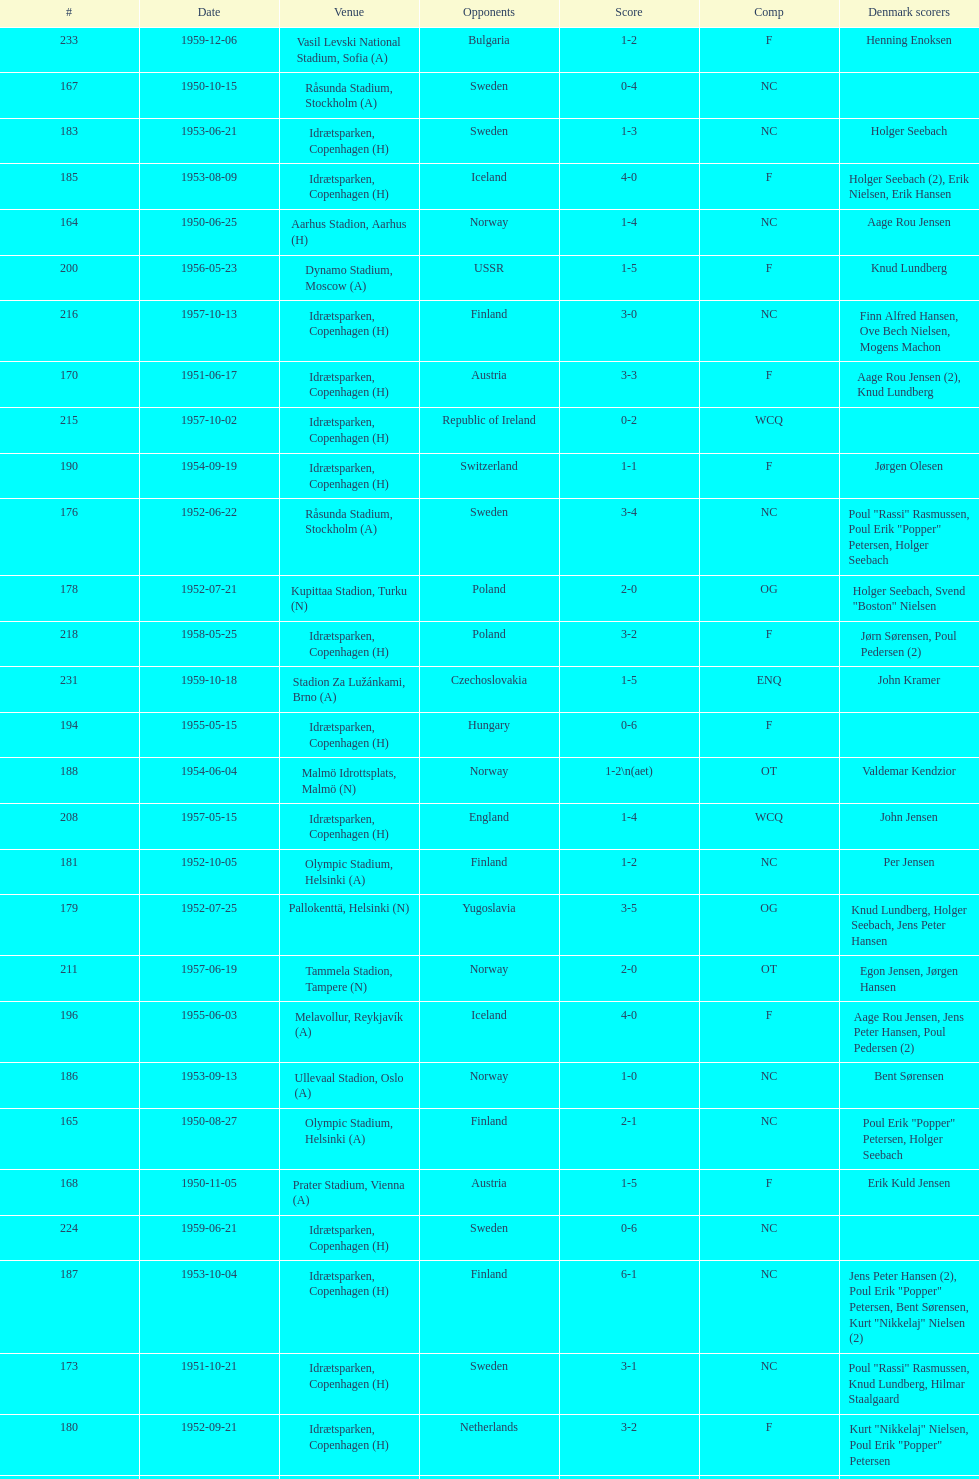What is the name of the venue listed before olympic stadium on 1950-08-27? Aarhus Stadion, Aarhus. 